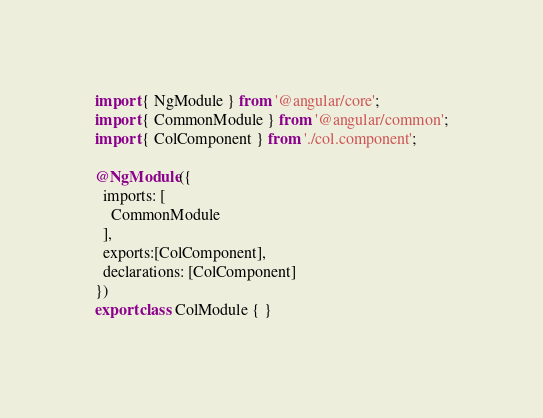Convert code to text. <code><loc_0><loc_0><loc_500><loc_500><_TypeScript_>import { NgModule } from '@angular/core';
import { CommonModule } from '@angular/common';
import { ColComponent } from './col.component';

@NgModule({
  imports: [
    CommonModule
  ],
  exports:[ColComponent],
  declarations: [ColComponent]
})
export class ColModule { }
</code> 